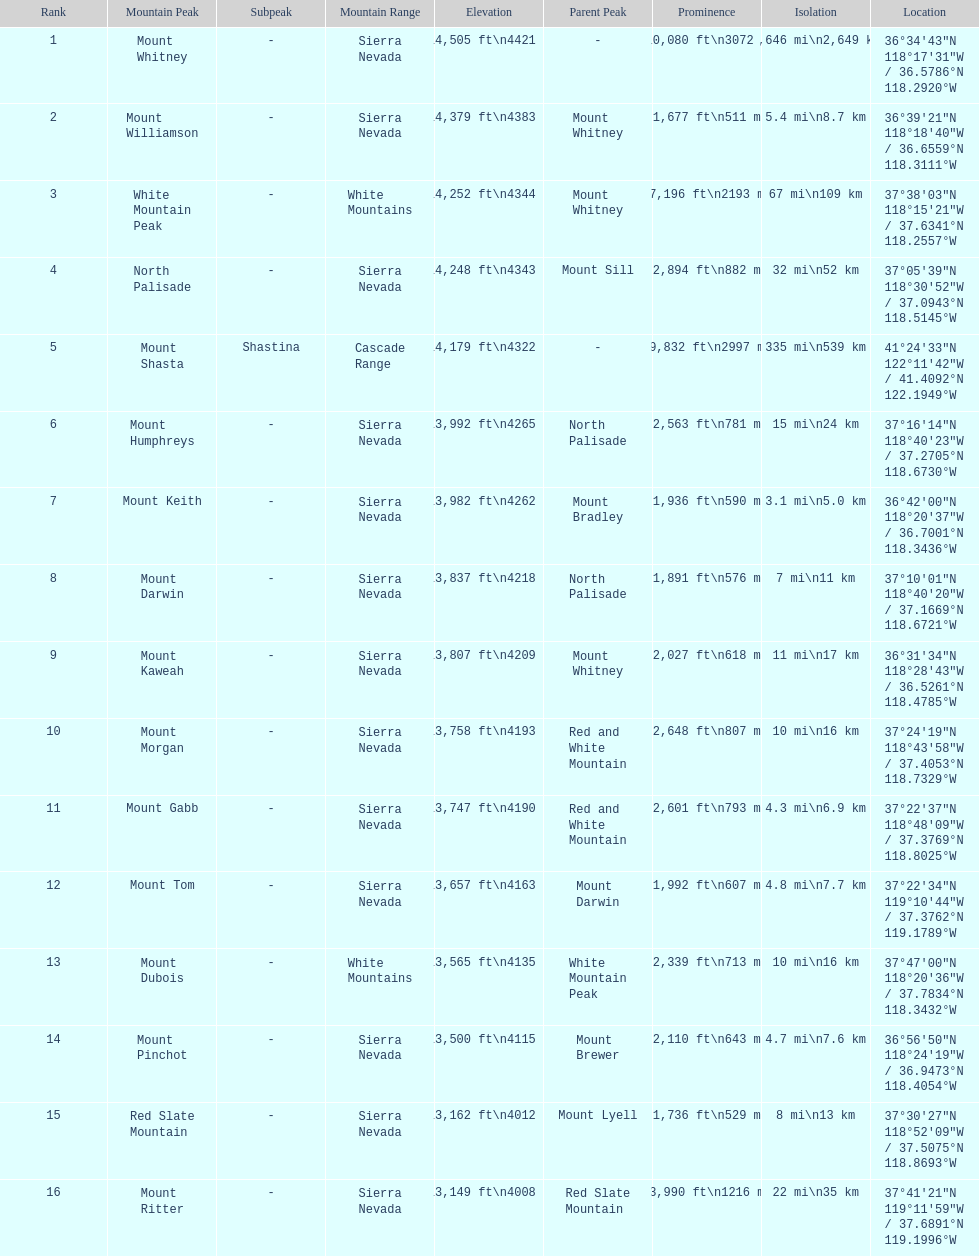In feet, what is the difference between the tallest peak and the 9th tallest peak in california? 698 ft. 